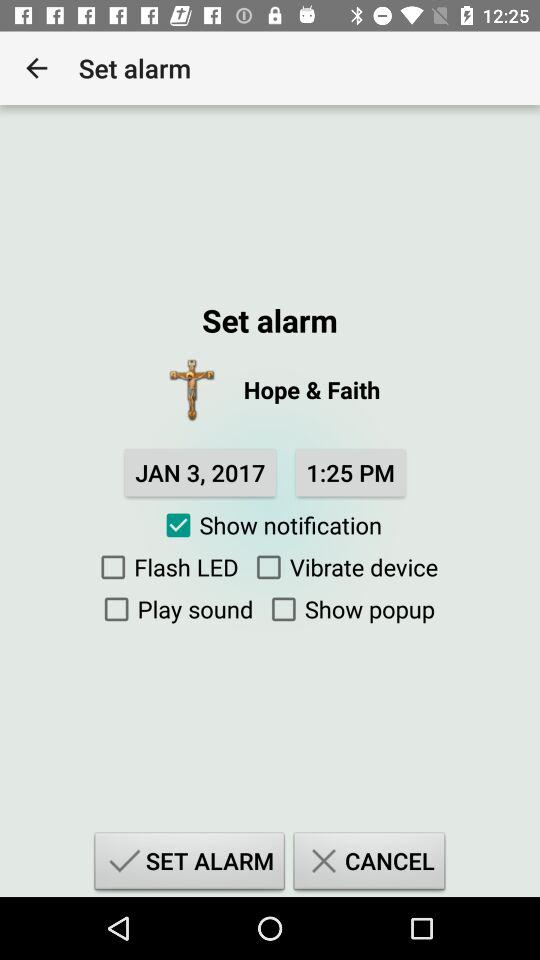What is the given time? The given time is 1:25 PM. 